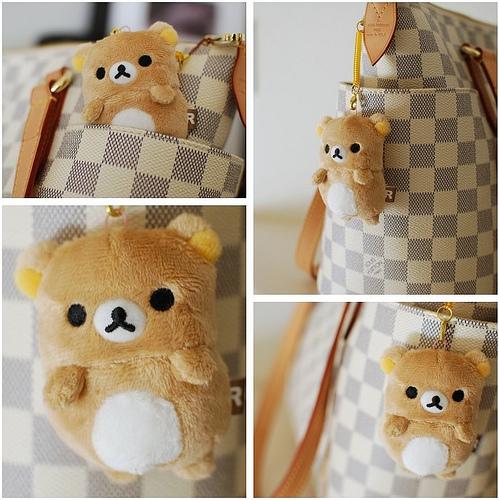What is this stuffed animal attached to?
Give a very brief answer. Purse. What pattern is on the purse?
Answer briefly. Checkered. What color are its eyes?
Short answer required. Black. 